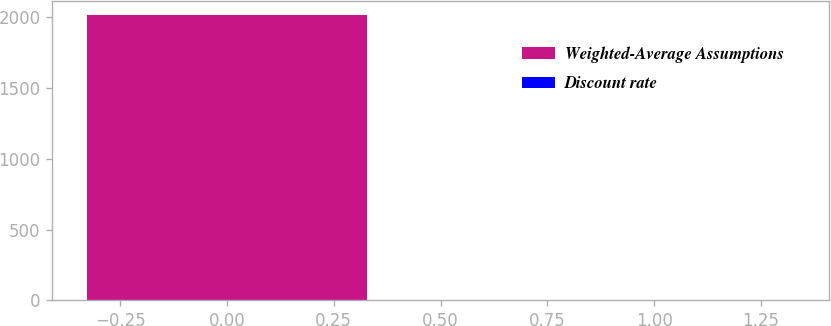<chart> <loc_0><loc_0><loc_500><loc_500><bar_chart><fcel>Weighted-Average Assumptions<fcel>Discount rate<nl><fcel>2013<fcel>4.31<nl></chart> 